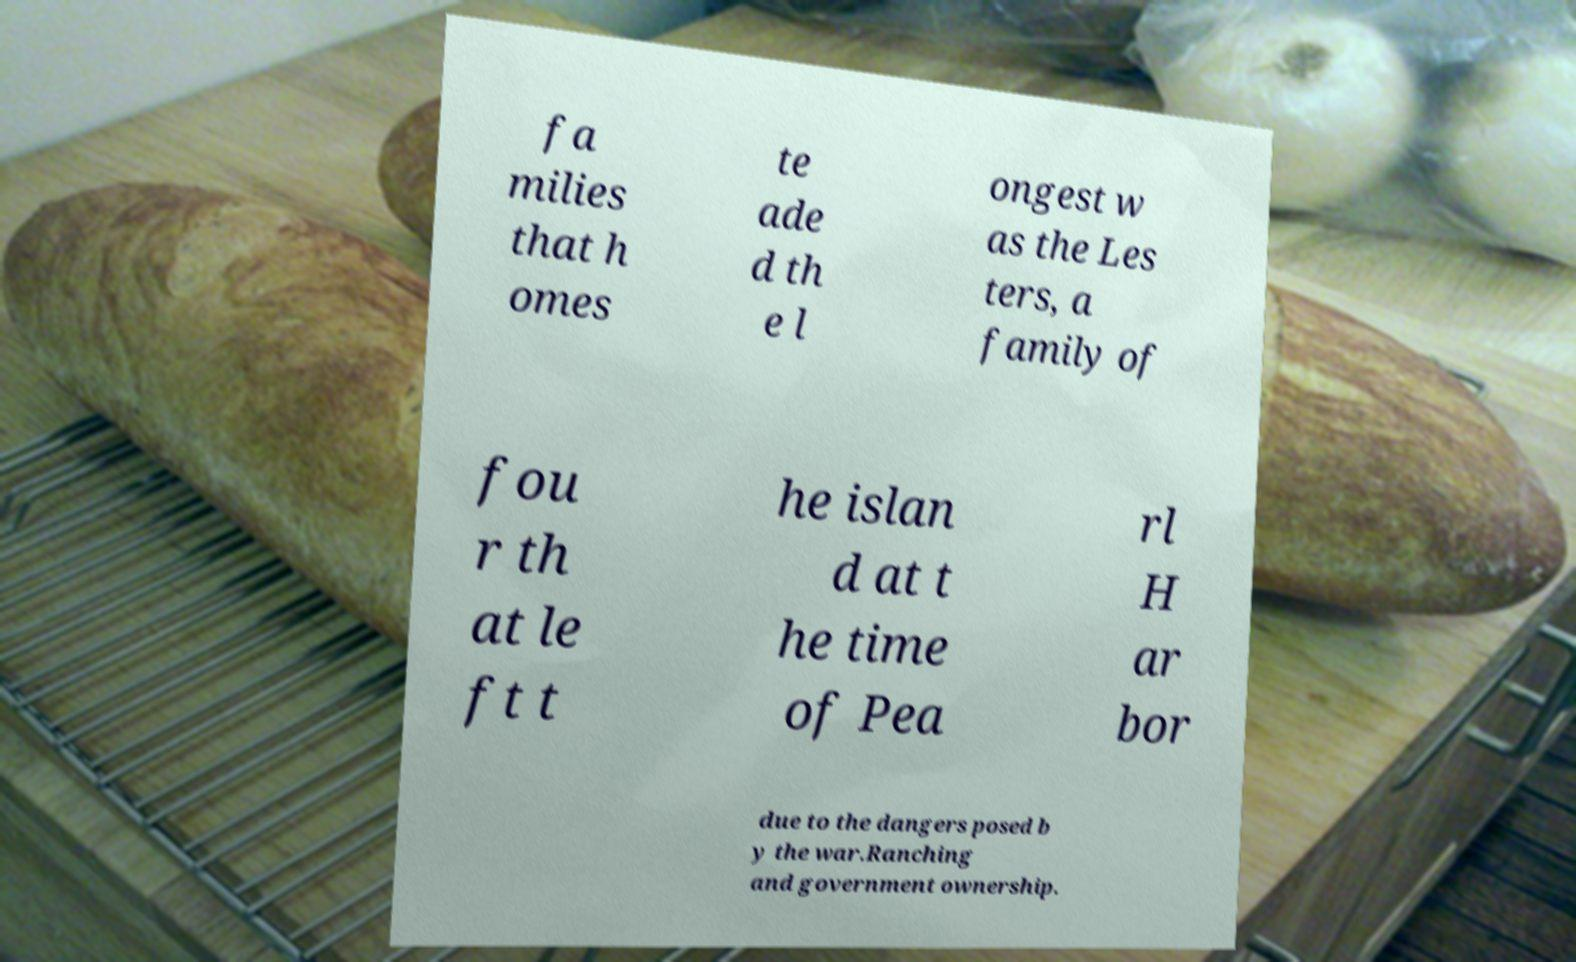Please identify and transcribe the text found in this image. fa milies that h omes te ade d th e l ongest w as the Les ters, a family of fou r th at le ft t he islan d at t he time of Pea rl H ar bor due to the dangers posed b y the war.Ranching and government ownership. 